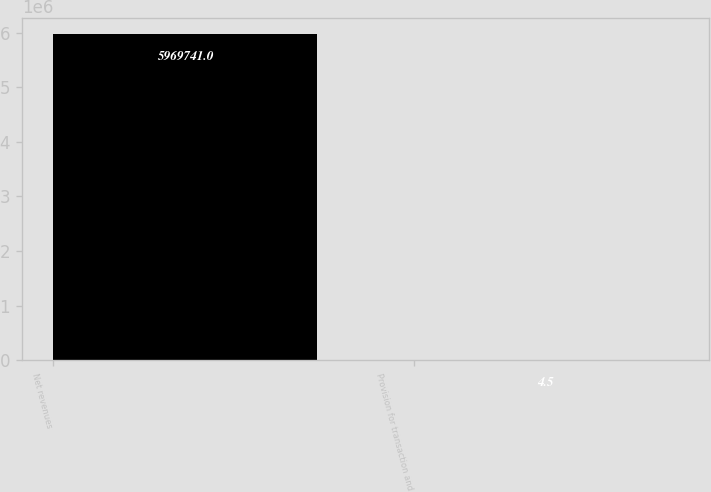<chart> <loc_0><loc_0><loc_500><loc_500><bar_chart><fcel>Net revenues<fcel>Provision for transaction and<nl><fcel>5.96974e+06<fcel>4.5<nl></chart> 